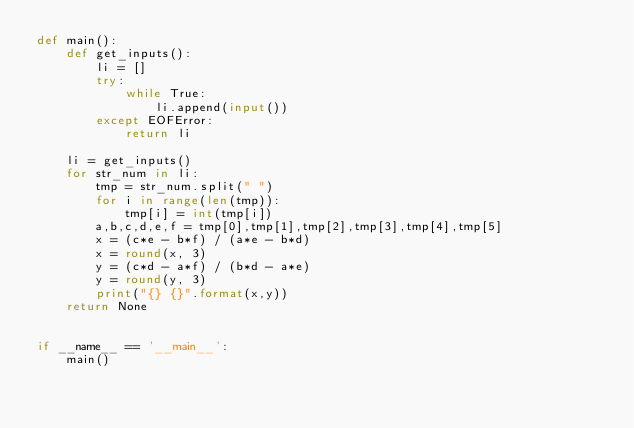Convert code to text. <code><loc_0><loc_0><loc_500><loc_500><_Python_>def main():
    def get_inputs():
        li = []
        try:
            while True:
                li.append(input())
        except EOFError:
            return li

    li = get_inputs()
    for str_num in li:
        tmp = str_num.split(" ")
        for i in range(len(tmp)):
            tmp[i] = int(tmp[i])
        a,b,c,d,e,f = tmp[0],tmp[1],tmp[2],tmp[3],tmp[4],tmp[5]
        x = (c*e - b*f) / (a*e - b*d)
        x = round(x, 3)
        y = (c*d - a*f) / (b*d - a*e)
        y = round(y, 3)
        print("{} {}".format(x,y))
    return None


if __name__ == '__main__':
    main()</code> 